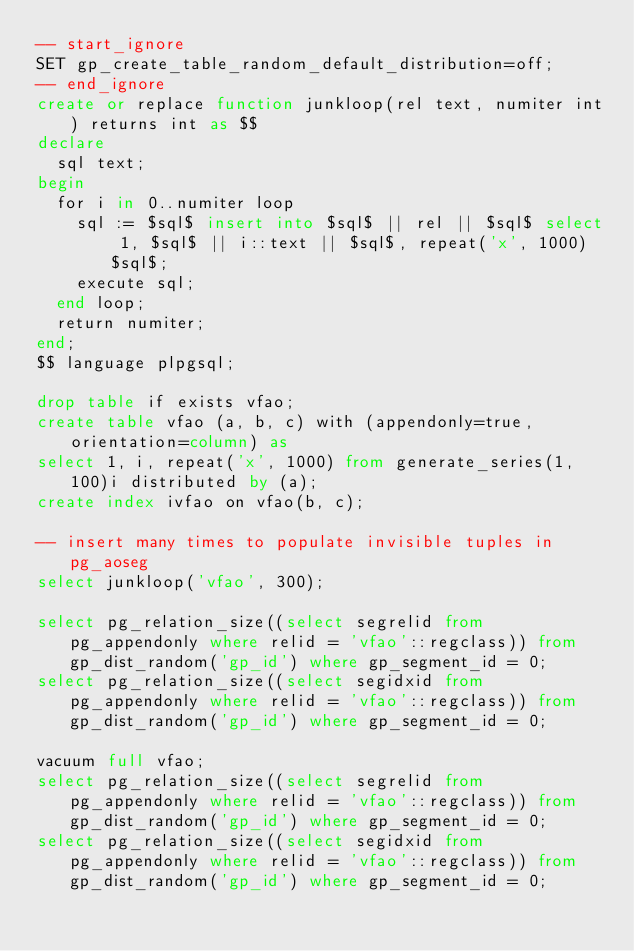<code> <loc_0><loc_0><loc_500><loc_500><_SQL_>-- start_ignore
SET gp_create_table_random_default_distribution=off;
-- end_ignore
create or replace function junkloop(rel text, numiter int) returns int as $$
declare
  sql text;
begin
  for i in 0..numiter loop
    sql := $sql$ insert into $sql$ || rel || $sql$ select 1, $sql$ || i::text || $sql$, repeat('x', 1000) $sql$;
    execute sql;
  end loop;
  return numiter;
end;
$$ language plpgsql;

drop table if exists vfao;
create table vfao (a, b, c) with (appendonly=true, orientation=column) as
select 1, i, repeat('x', 1000) from generate_series(1, 100)i distributed by (a);
create index ivfao on vfao(b, c);

-- insert many times to populate invisible tuples in pg_aoseg
select junkloop('vfao', 300);

select pg_relation_size((select segrelid from pg_appendonly where relid = 'vfao'::regclass)) from gp_dist_random('gp_id') where gp_segment_id = 0;
select pg_relation_size((select segidxid from pg_appendonly where relid = 'vfao'::regclass)) from gp_dist_random('gp_id') where gp_segment_id = 0;

vacuum full vfao;
select pg_relation_size((select segrelid from pg_appendonly where relid = 'vfao'::regclass)) from gp_dist_random('gp_id') where gp_segment_id = 0;
select pg_relation_size((select segidxid from pg_appendonly where relid = 'vfao'::regclass)) from gp_dist_random('gp_id') where gp_segment_id = 0;
</code> 